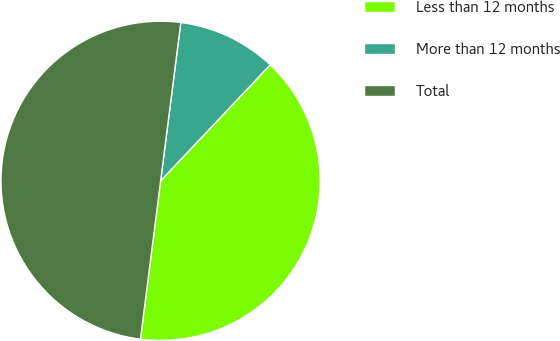<chart> <loc_0><loc_0><loc_500><loc_500><pie_chart><fcel>Less than 12 months<fcel>More than 12 months<fcel>Total<nl><fcel>39.97%<fcel>10.03%<fcel>50.0%<nl></chart> 